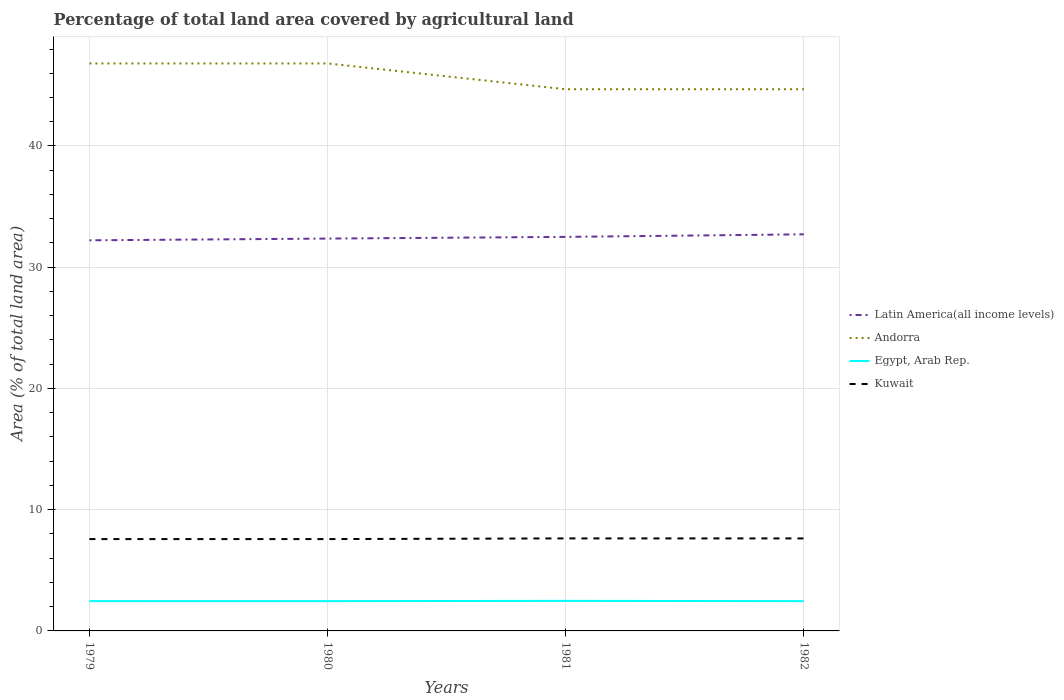How many different coloured lines are there?
Ensure brevity in your answer.  4. Is the number of lines equal to the number of legend labels?
Provide a short and direct response. Yes. Across all years, what is the maximum percentage of agricultural land in Egypt, Arab Rep.?
Give a very brief answer. 2.46. What is the total percentage of agricultural land in Kuwait in the graph?
Provide a short and direct response. 0. What is the difference between the highest and the second highest percentage of agricultural land in Egypt, Arab Rep.?
Offer a terse response. 0.02. What is the difference between the highest and the lowest percentage of agricultural land in Kuwait?
Provide a short and direct response. 2. Is the percentage of agricultural land in Kuwait strictly greater than the percentage of agricultural land in Egypt, Arab Rep. over the years?
Your answer should be very brief. No. How many lines are there?
Keep it short and to the point. 4. What is the difference between two consecutive major ticks on the Y-axis?
Offer a terse response. 10. Where does the legend appear in the graph?
Keep it short and to the point. Center right. How many legend labels are there?
Your response must be concise. 4. What is the title of the graph?
Your response must be concise. Percentage of total land area covered by agricultural land. What is the label or title of the X-axis?
Offer a very short reply. Years. What is the label or title of the Y-axis?
Provide a short and direct response. Area (% of total land area). What is the Area (% of total land area) in Latin America(all income levels) in 1979?
Keep it short and to the point. 32.22. What is the Area (% of total land area) of Andorra in 1979?
Your response must be concise. 46.81. What is the Area (% of total land area) of Egypt, Arab Rep. in 1979?
Offer a terse response. 2.46. What is the Area (% of total land area) of Kuwait in 1979?
Offer a terse response. 7.58. What is the Area (% of total land area) of Latin America(all income levels) in 1980?
Your answer should be very brief. 32.36. What is the Area (% of total land area) in Andorra in 1980?
Offer a very short reply. 46.81. What is the Area (% of total land area) of Egypt, Arab Rep. in 1980?
Give a very brief answer. 2.46. What is the Area (% of total land area) of Kuwait in 1980?
Make the answer very short. 7.58. What is the Area (% of total land area) in Latin America(all income levels) in 1981?
Provide a succinct answer. 32.5. What is the Area (% of total land area) of Andorra in 1981?
Offer a very short reply. 44.68. What is the Area (% of total land area) of Egypt, Arab Rep. in 1981?
Your answer should be very brief. 2.48. What is the Area (% of total land area) of Kuwait in 1981?
Give a very brief answer. 7.63. What is the Area (% of total land area) of Latin America(all income levels) in 1982?
Your response must be concise. 32.71. What is the Area (% of total land area) in Andorra in 1982?
Offer a terse response. 44.68. What is the Area (% of total land area) in Egypt, Arab Rep. in 1982?
Your answer should be compact. 2.46. What is the Area (% of total land area) in Kuwait in 1982?
Your response must be concise. 7.63. Across all years, what is the maximum Area (% of total land area) of Latin America(all income levels)?
Make the answer very short. 32.71. Across all years, what is the maximum Area (% of total land area) in Andorra?
Your answer should be very brief. 46.81. Across all years, what is the maximum Area (% of total land area) of Egypt, Arab Rep.?
Your answer should be very brief. 2.48. Across all years, what is the maximum Area (% of total land area) of Kuwait?
Offer a terse response. 7.63. Across all years, what is the minimum Area (% of total land area) of Latin America(all income levels)?
Provide a succinct answer. 32.22. Across all years, what is the minimum Area (% of total land area) in Andorra?
Make the answer very short. 44.68. Across all years, what is the minimum Area (% of total land area) in Egypt, Arab Rep.?
Your answer should be compact. 2.46. Across all years, what is the minimum Area (% of total land area) in Kuwait?
Your response must be concise. 7.58. What is the total Area (% of total land area) of Latin America(all income levels) in the graph?
Your answer should be very brief. 129.8. What is the total Area (% of total land area) of Andorra in the graph?
Keep it short and to the point. 182.98. What is the total Area (% of total land area) in Egypt, Arab Rep. in the graph?
Your answer should be compact. 9.85. What is the total Area (% of total land area) in Kuwait in the graph?
Provide a short and direct response. 30.42. What is the difference between the Area (% of total land area) of Latin America(all income levels) in 1979 and that in 1980?
Ensure brevity in your answer.  -0.14. What is the difference between the Area (% of total land area) in Egypt, Arab Rep. in 1979 and that in 1980?
Provide a short and direct response. 0. What is the difference between the Area (% of total land area) of Latin America(all income levels) in 1979 and that in 1981?
Your answer should be compact. -0.28. What is the difference between the Area (% of total land area) in Andorra in 1979 and that in 1981?
Your response must be concise. 2.13. What is the difference between the Area (% of total land area) of Egypt, Arab Rep. in 1979 and that in 1981?
Your answer should be very brief. -0.02. What is the difference between the Area (% of total land area) of Kuwait in 1979 and that in 1981?
Your response must be concise. -0.06. What is the difference between the Area (% of total land area) in Latin America(all income levels) in 1979 and that in 1982?
Offer a terse response. -0.49. What is the difference between the Area (% of total land area) in Andorra in 1979 and that in 1982?
Make the answer very short. 2.13. What is the difference between the Area (% of total land area) in Egypt, Arab Rep. in 1979 and that in 1982?
Offer a very short reply. 0. What is the difference between the Area (% of total land area) in Kuwait in 1979 and that in 1982?
Provide a succinct answer. -0.06. What is the difference between the Area (% of total land area) in Latin America(all income levels) in 1980 and that in 1981?
Provide a succinct answer. -0.14. What is the difference between the Area (% of total land area) of Andorra in 1980 and that in 1981?
Your answer should be compact. 2.13. What is the difference between the Area (% of total land area) in Egypt, Arab Rep. in 1980 and that in 1981?
Your response must be concise. -0.02. What is the difference between the Area (% of total land area) in Kuwait in 1980 and that in 1981?
Offer a very short reply. -0.06. What is the difference between the Area (% of total land area) of Latin America(all income levels) in 1980 and that in 1982?
Your answer should be compact. -0.35. What is the difference between the Area (% of total land area) of Andorra in 1980 and that in 1982?
Your answer should be compact. 2.13. What is the difference between the Area (% of total land area) in Egypt, Arab Rep. in 1980 and that in 1982?
Ensure brevity in your answer.  -0. What is the difference between the Area (% of total land area) in Kuwait in 1980 and that in 1982?
Provide a succinct answer. -0.06. What is the difference between the Area (% of total land area) of Latin America(all income levels) in 1981 and that in 1982?
Ensure brevity in your answer.  -0.21. What is the difference between the Area (% of total land area) of Egypt, Arab Rep. in 1981 and that in 1982?
Offer a very short reply. 0.02. What is the difference between the Area (% of total land area) in Latin America(all income levels) in 1979 and the Area (% of total land area) in Andorra in 1980?
Offer a terse response. -14.59. What is the difference between the Area (% of total land area) of Latin America(all income levels) in 1979 and the Area (% of total land area) of Egypt, Arab Rep. in 1980?
Your answer should be compact. 29.76. What is the difference between the Area (% of total land area) in Latin America(all income levels) in 1979 and the Area (% of total land area) in Kuwait in 1980?
Ensure brevity in your answer.  24.64. What is the difference between the Area (% of total land area) of Andorra in 1979 and the Area (% of total land area) of Egypt, Arab Rep. in 1980?
Give a very brief answer. 44.35. What is the difference between the Area (% of total land area) of Andorra in 1979 and the Area (% of total land area) of Kuwait in 1980?
Give a very brief answer. 39.23. What is the difference between the Area (% of total land area) in Egypt, Arab Rep. in 1979 and the Area (% of total land area) in Kuwait in 1980?
Offer a very short reply. -5.12. What is the difference between the Area (% of total land area) in Latin America(all income levels) in 1979 and the Area (% of total land area) in Andorra in 1981?
Make the answer very short. -12.46. What is the difference between the Area (% of total land area) of Latin America(all income levels) in 1979 and the Area (% of total land area) of Egypt, Arab Rep. in 1981?
Offer a very short reply. 29.74. What is the difference between the Area (% of total land area) in Latin America(all income levels) in 1979 and the Area (% of total land area) in Kuwait in 1981?
Provide a succinct answer. 24.59. What is the difference between the Area (% of total land area) in Andorra in 1979 and the Area (% of total land area) in Egypt, Arab Rep. in 1981?
Provide a short and direct response. 44.33. What is the difference between the Area (% of total land area) of Andorra in 1979 and the Area (% of total land area) of Kuwait in 1981?
Provide a succinct answer. 39.18. What is the difference between the Area (% of total land area) in Egypt, Arab Rep. in 1979 and the Area (% of total land area) in Kuwait in 1981?
Make the answer very short. -5.17. What is the difference between the Area (% of total land area) in Latin America(all income levels) in 1979 and the Area (% of total land area) in Andorra in 1982?
Give a very brief answer. -12.46. What is the difference between the Area (% of total land area) of Latin America(all income levels) in 1979 and the Area (% of total land area) of Egypt, Arab Rep. in 1982?
Your answer should be very brief. 29.76. What is the difference between the Area (% of total land area) in Latin America(all income levels) in 1979 and the Area (% of total land area) in Kuwait in 1982?
Offer a very short reply. 24.59. What is the difference between the Area (% of total land area) of Andorra in 1979 and the Area (% of total land area) of Egypt, Arab Rep. in 1982?
Ensure brevity in your answer.  44.35. What is the difference between the Area (% of total land area) in Andorra in 1979 and the Area (% of total land area) in Kuwait in 1982?
Offer a very short reply. 39.18. What is the difference between the Area (% of total land area) of Egypt, Arab Rep. in 1979 and the Area (% of total land area) of Kuwait in 1982?
Keep it short and to the point. -5.17. What is the difference between the Area (% of total land area) of Latin America(all income levels) in 1980 and the Area (% of total land area) of Andorra in 1981?
Provide a succinct answer. -12.32. What is the difference between the Area (% of total land area) in Latin America(all income levels) in 1980 and the Area (% of total land area) in Egypt, Arab Rep. in 1981?
Provide a succinct answer. 29.88. What is the difference between the Area (% of total land area) in Latin America(all income levels) in 1980 and the Area (% of total land area) in Kuwait in 1981?
Make the answer very short. 24.73. What is the difference between the Area (% of total land area) of Andorra in 1980 and the Area (% of total land area) of Egypt, Arab Rep. in 1981?
Your answer should be compact. 44.33. What is the difference between the Area (% of total land area) in Andorra in 1980 and the Area (% of total land area) in Kuwait in 1981?
Provide a short and direct response. 39.18. What is the difference between the Area (% of total land area) of Egypt, Arab Rep. in 1980 and the Area (% of total land area) of Kuwait in 1981?
Your response must be concise. -5.18. What is the difference between the Area (% of total land area) in Latin America(all income levels) in 1980 and the Area (% of total land area) in Andorra in 1982?
Keep it short and to the point. -12.32. What is the difference between the Area (% of total land area) in Latin America(all income levels) in 1980 and the Area (% of total land area) in Egypt, Arab Rep. in 1982?
Offer a terse response. 29.91. What is the difference between the Area (% of total land area) of Latin America(all income levels) in 1980 and the Area (% of total land area) of Kuwait in 1982?
Make the answer very short. 24.73. What is the difference between the Area (% of total land area) in Andorra in 1980 and the Area (% of total land area) in Egypt, Arab Rep. in 1982?
Keep it short and to the point. 44.35. What is the difference between the Area (% of total land area) of Andorra in 1980 and the Area (% of total land area) of Kuwait in 1982?
Provide a succinct answer. 39.18. What is the difference between the Area (% of total land area) in Egypt, Arab Rep. in 1980 and the Area (% of total land area) in Kuwait in 1982?
Keep it short and to the point. -5.18. What is the difference between the Area (% of total land area) of Latin America(all income levels) in 1981 and the Area (% of total land area) of Andorra in 1982?
Your response must be concise. -12.18. What is the difference between the Area (% of total land area) in Latin America(all income levels) in 1981 and the Area (% of total land area) in Egypt, Arab Rep. in 1982?
Your answer should be very brief. 30.05. What is the difference between the Area (% of total land area) of Latin America(all income levels) in 1981 and the Area (% of total land area) of Kuwait in 1982?
Ensure brevity in your answer.  24.87. What is the difference between the Area (% of total land area) of Andorra in 1981 and the Area (% of total land area) of Egypt, Arab Rep. in 1982?
Ensure brevity in your answer.  42.22. What is the difference between the Area (% of total land area) of Andorra in 1981 and the Area (% of total land area) of Kuwait in 1982?
Provide a short and direct response. 37.05. What is the difference between the Area (% of total land area) in Egypt, Arab Rep. in 1981 and the Area (% of total land area) in Kuwait in 1982?
Give a very brief answer. -5.15. What is the average Area (% of total land area) of Latin America(all income levels) per year?
Offer a terse response. 32.45. What is the average Area (% of total land area) of Andorra per year?
Make the answer very short. 45.74. What is the average Area (% of total land area) in Egypt, Arab Rep. per year?
Make the answer very short. 2.46. What is the average Area (% of total land area) of Kuwait per year?
Ensure brevity in your answer.  7.6. In the year 1979, what is the difference between the Area (% of total land area) of Latin America(all income levels) and Area (% of total land area) of Andorra?
Give a very brief answer. -14.59. In the year 1979, what is the difference between the Area (% of total land area) in Latin America(all income levels) and Area (% of total land area) in Egypt, Arab Rep.?
Provide a short and direct response. 29.76. In the year 1979, what is the difference between the Area (% of total land area) in Latin America(all income levels) and Area (% of total land area) in Kuwait?
Offer a very short reply. 24.64. In the year 1979, what is the difference between the Area (% of total land area) in Andorra and Area (% of total land area) in Egypt, Arab Rep.?
Provide a succinct answer. 44.35. In the year 1979, what is the difference between the Area (% of total land area) in Andorra and Area (% of total land area) in Kuwait?
Offer a very short reply. 39.23. In the year 1979, what is the difference between the Area (% of total land area) in Egypt, Arab Rep. and Area (% of total land area) in Kuwait?
Your response must be concise. -5.12. In the year 1980, what is the difference between the Area (% of total land area) in Latin America(all income levels) and Area (% of total land area) in Andorra?
Provide a succinct answer. -14.44. In the year 1980, what is the difference between the Area (% of total land area) in Latin America(all income levels) and Area (% of total land area) in Egypt, Arab Rep.?
Ensure brevity in your answer.  29.91. In the year 1980, what is the difference between the Area (% of total land area) in Latin America(all income levels) and Area (% of total land area) in Kuwait?
Offer a very short reply. 24.79. In the year 1980, what is the difference between the Area (% of total land area) of Andorra and Area (% of total land area) of Egypt, Arab Rep.?
Ensure brevity in your answer.  44.35. In the year 1980, what is the difference between the Area (% of total land area) in Andorra and Area (% of total land area) in Kuwait?
Offer a terse response. 39.23. In the year 1980, what is the difference between the Area (% of total land area) in Egypt, Arab Rep. and Area (% of total land area) in Kuwait?
Provide a succinct answer. -5.12. In the year 1981, what is the difference between the Area (% of total land area) in Latin America(all income levels) and Area (% of total land area) in Andorra?
Make the answer very short. -12.18. In the year 1981, what is the difference between the Area (% of total land area) of Latin America(all income levels) and Area (% of total land area) of Egypt, Arab Rep.?
Your response must be concise. 30.02. In the year 1981, what is the difference between the Area (% of total land area) of Latin America(all income levels) and Area (% of total land area) of Kuwait?
Keep it short and to the point. 24.87. In the year 1981, what is the difference between the Area (% of total land area) in Andorra and Area (% of total land area) in Egypt, Arab Rep.?
Ensure brevity in your answer.  42.2. In the year 1981, what is the difference between the Area (% of total land area) in Andorra and Area (% of total land area) in Kuwait?
Your response must be concise. 37.05. In the year 1981, what is the difference between the Area (% of total land area) of Egypt, Arab Rep. and Area (% of total land area) of Kuwait?
Make the answer very short. -5.15. In the year 1982, what is the difference between the Area (% of total land area) in Latin America(all income levels) and Area (% of total land area) in Andorra?
Your answer should be compact. -11.97. In the year 1982, what is the difference between the Area (% of total land area) in Latin America(all income levels) and Area (% of total land area) in Egypt, Arab Rep.?
Your answer should be compact. 30.26. In the year 1982, what is the difference between the Area (% of total land area) of Latin America(all income levels) and Area (% of total land area) of Kuwait?
Keep it short and to the point. 25.08. In the year 1982, what is the difference between the Area (% of total land area) of Andorra and Area (% of total land area) of Egypt, Arab Rep.?
Ensure brevity in your answer.  42.22. In the year 1982, what is the difference between the Area (% of total land area) of Andorra and Area (% of total land area) of Kuwait?
Provide a succinct answer. 37.05. In the year 1982, what is the difference between the Area (% of total land area) of Egypt, Arab Rep. and Area (% of total land area) of Kuwait?
Your response must be concise. -5.18. What is the ratio of the Area (% of total land area) in Latin America(all income levels) in 1979 to that in 1980?
Offer a terse response. 1. What is the ratio of the Area (% of total land area) in Egypt, Arab Rep. in 1979 to that in 1980?
Keep it short and to the point. 1. What is the ratio of the Area (% of total land area) in Andorra in 1979 to that in 1981?
Make the answer very short. 1.05. What is the ratio of the Area (% of total land area) of Kuwait in 1979 to that in 1981?
Ensure brevity in your answer.  0.99. What is the ratio of the Area (% of total land area) of Latin America(all income levels) in 1979 to that in 1982?
Your answer should be compact. 0.98. What is the ratio of the Area (% of total land area) of Andorra in 1979 to that in 1982?
Make the answer very short. 1.05. What is the ratio of the Area (% of total land area) in Latin America(all income levels) in 1980 to that in 1981?
Provide a succinct answer. 1. What is the ratio of the Area (% of total land area) of Andorra in 1980 to that in 1981?
Offer a very short reply. 1.05. What is the ratio of the Area (% of total land area) in Egypt, Arab Rep. in 1980 to that in 1981?
Keep it short and to the point. 0.99. What is the ratio of the Area (% of total land area) in Kuwait in 1980 to that in 1981?
Keep it short and to the point. 0.99. What is the ratio of the Area (% of total land area) in Latin America(all income levels) in 1980 to that in 1982?
Ensure brevity in your answer.  0.99. What is the ratio of the Area (% of total land area) of Andorra in 1980 to that in 1982?
Provide a short and direct response. 1.05. What is the ratio of the Area (% of total land area) of Egypt, Arab Rep. in 1980 to that in 1982?
Make the answer very short. 1. What is the ratio of the Area (% of total land area) of Kuwait in 1980 to that in 1982?
Your response must be concise. 0.99. What is the ratio of the Area (% of total land area) of Egypt, Arab Rep. in 1981 to that in 1982?
Offer a terse response. 1.01. What is the ratio of the Area (% of total land area) of Kuwait in 1981 to that in 1982?
Give a very brief answer. 1. What is the difference between the highest and the second highest Area (% of total land area) in Latin America(all income levels)?
Keep it short and to the point. 0.21. What is the difference between the highest and the second highest Area (% of total land area) in Andorra?
Your answer should be very brief. 0. What is the difference between the highest and the second highest Area (% of total land area) in Egypt, Arab Rep.?
Offer a very short reply. 0.02. What is the difference between the highest and the lowest Area (% of total land area) in Latin America(all income levels)?
Keep it short and to the point. 0.49. What is the difference between the highest and the lowest Area (% of total land area) of Andorra?
Offer a very short reply. 2.13. What is the difference between the highest and the lowest Area (% of total land area) in Egypt, Arab Rep.?
Provide a succinct answer. 0.02. What is the difference between the highest and the lowest Area (% of total land area) of Kuwait?
Offer a very short reply. 0.06. 